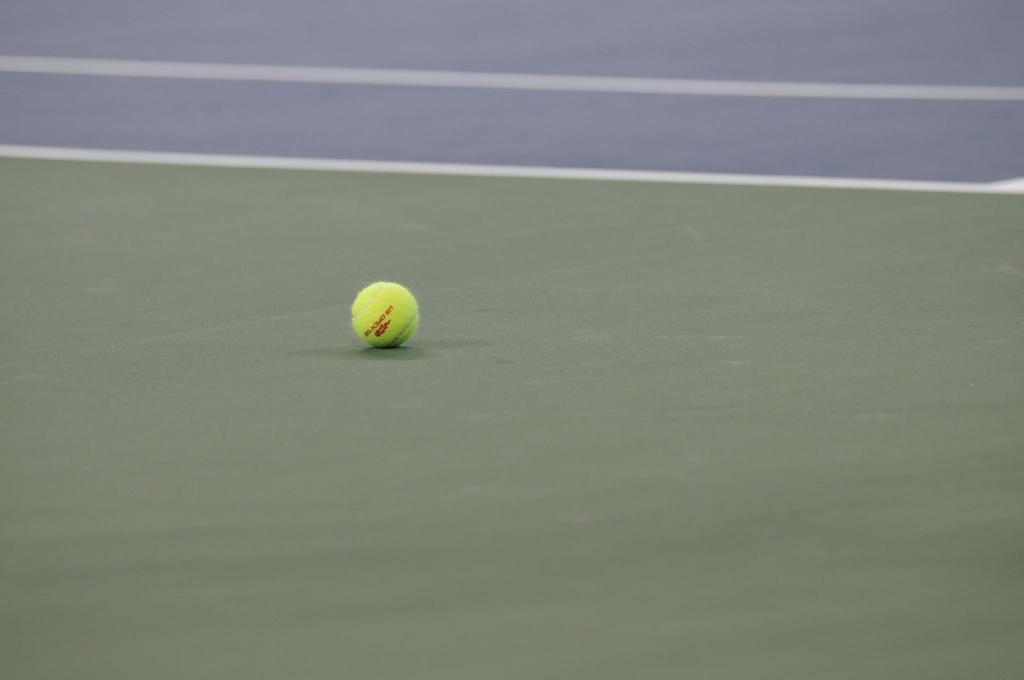What object is present in the image? There is a tennis ball in the image. What type of location is depicted in the image? The image appears to be of a tennis court. How does the beggar use magic to influence the outcome of the tennis match in the image? There is no beggar or magic present in the image; it only features a tennis ball and a tennis court. 